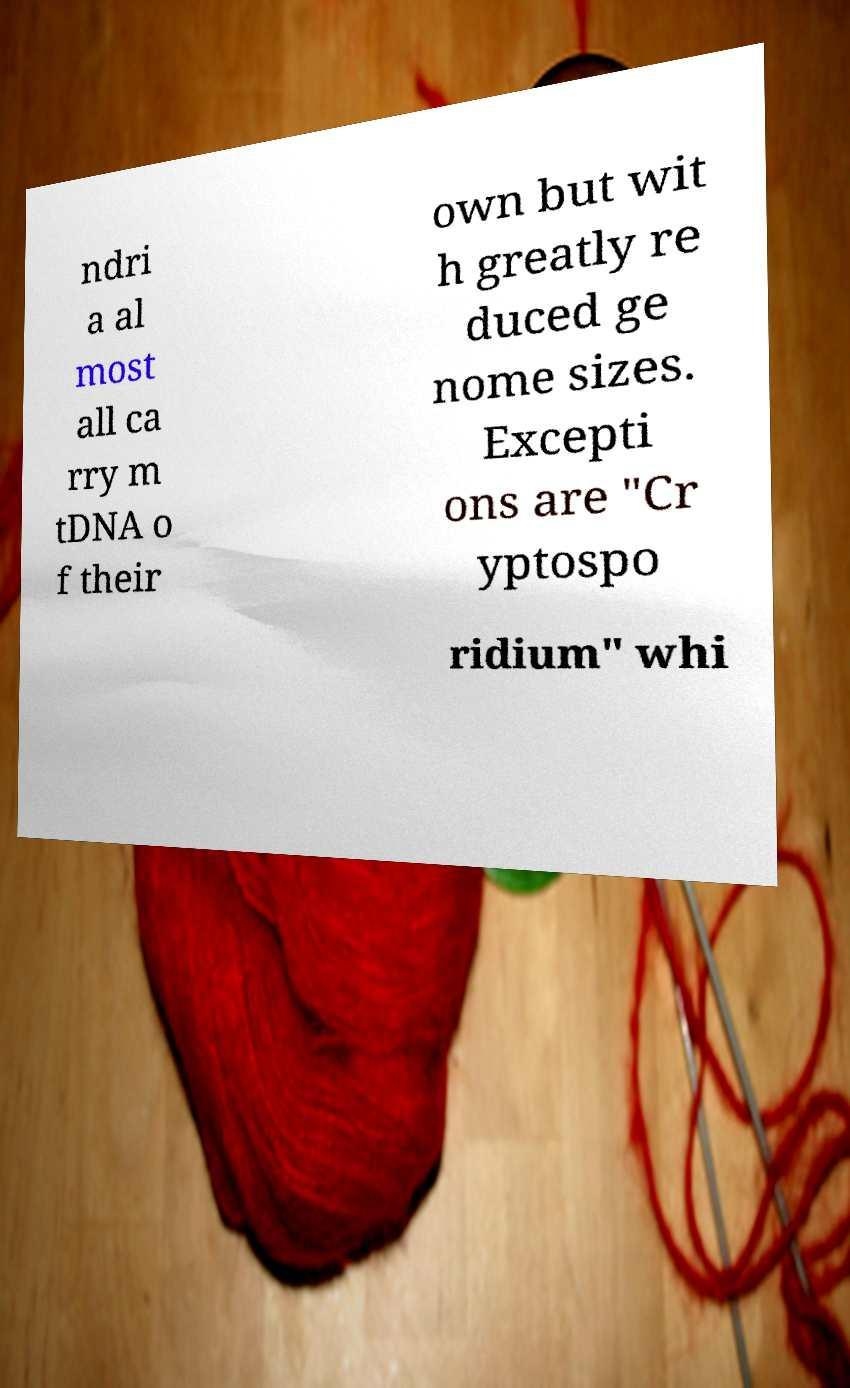There's text embedded in this image that I need extracted. Can you transcribe it verbatim? ndri a al most all ca rry m tDNA o f their own but wit h greatly re duced ge nome sizes. Excepti ons are "Cr yptospo ridium" whi 